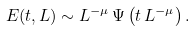Convert formula to latex. <formula><loc_0><loc_0><loc_500><loc_500>E ( t , L ) \sim L ^ { - \mu } \, \Psi \left ( t \, L ^ { - \mu } \right ) .</formula> 